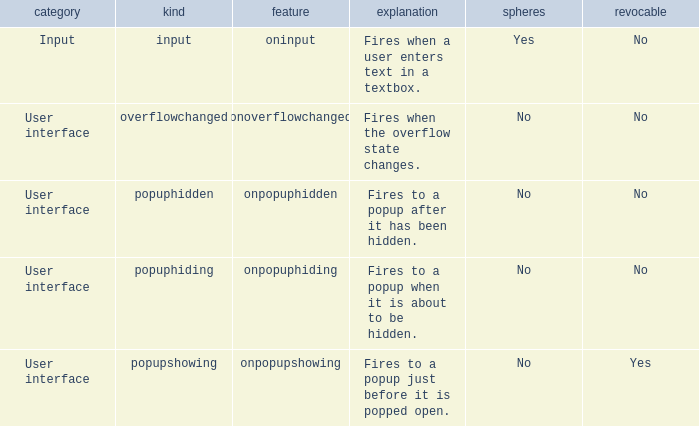Parse the full table. {'header': ['category', 'kind', 'feature', 'explanation', 'spheres', 'revocable'], 'rows': [['Input', 'input', 'oninput', 'Fires when a user enters text in a textbox.', 'Yes', 'No'], ['User interface', 'overflowchanged', 'onoverflowchanged', 'Fires when the overflow state changes.', 'No', 'No'], ['User interface', 'popuphidden', 'onpopuphidden', 'Fires to a popup after it has been hidden.', 'No', 'No'], ['User interface', 'popuphiding', 'onpopuphiding', 'Fires to a popup when it is about to be hidden.', 'No', 'No'], ['User interface', 'popupshowing', 'onpopupshowing', 'Fires to a popup just before it is popped open.', 'No', 'Yes']]} What's the bubbles with attribute being onpopuphidden No. 